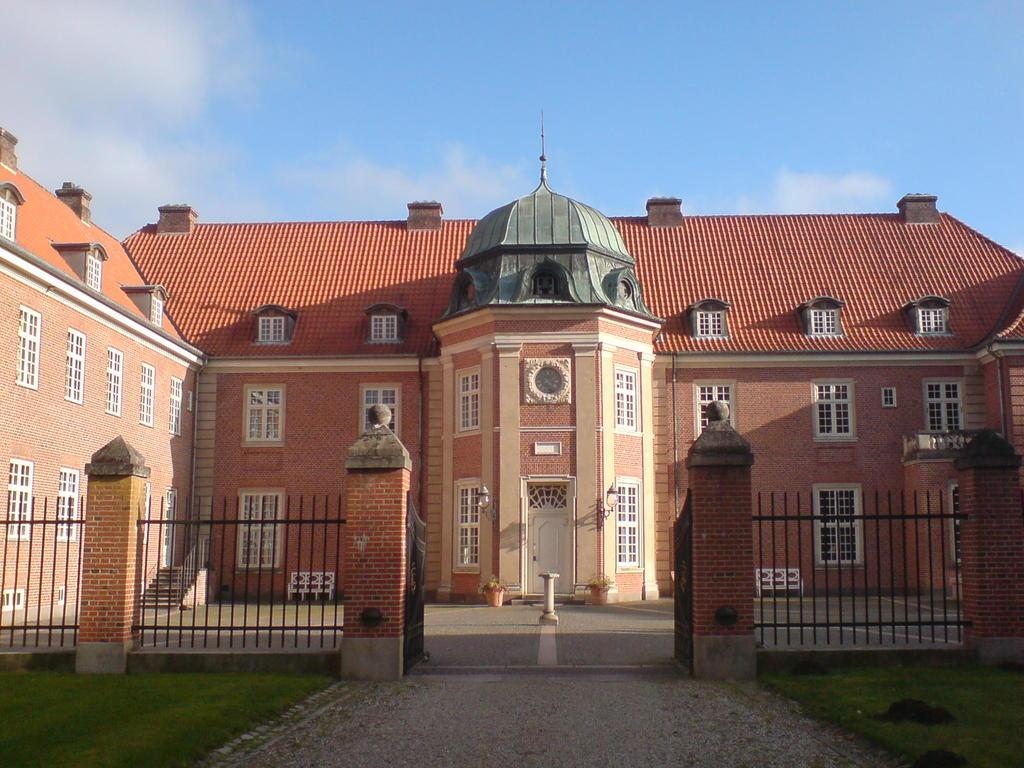What type of vegetation is present on the ground in the front of the image? There is grass on the ground in the front of the image. What can be seen in the center of the image? There is a fence and gates in the center of the image. What is visible in the background of the image? There is a building and a cloudy sky in the background of the image. Where is the quilt stored in the image? There is no quilt present in the image. What type of surprise can be seen in the image? There is no surprise depicted in the image; it features a fence, gates, a building, and a cloudy sky. 